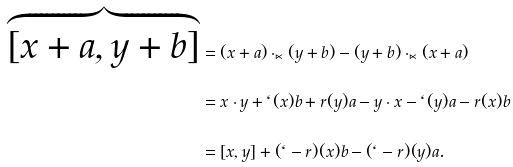<formula> <loc_0><loc_0><loc_500><loc_500>\overbrace { [ x + a , y + b ] } & = ( x + a ) \cdot _ { \ltimes } ( y + b ) - ( y + b ) \cdot _ { \ltimes } ( x + a ) \\ & = x \cdot y + \ell ( x ) b + r ( y ) a - y \cdot x - \ell ( y ) a - r ( x ) b \\ & = [ x , y ] + ( \ell - r ) ( x ) b - ( \ell - r ) ( y ) a .</formula> 